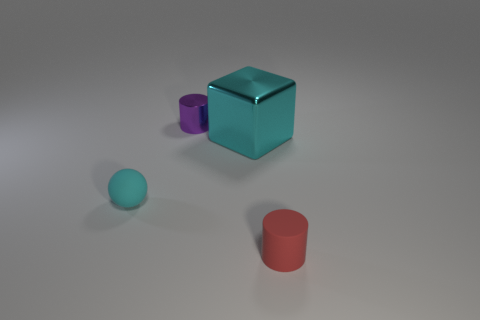Add 4 red balls. How many objects exist? 8 Subtract all balls. How many objects are left? 3 Add 2 small matte cylinders. How many small matte cylinders are left? 3 Add 2 big gray metal spheres. How many big gray metal spheres exist? 2 Subtract 0 gray cubes. How many objects are left? 4 Subtract all gray cylinders. Subtract all cyan cubes. How many objects are left? 3 